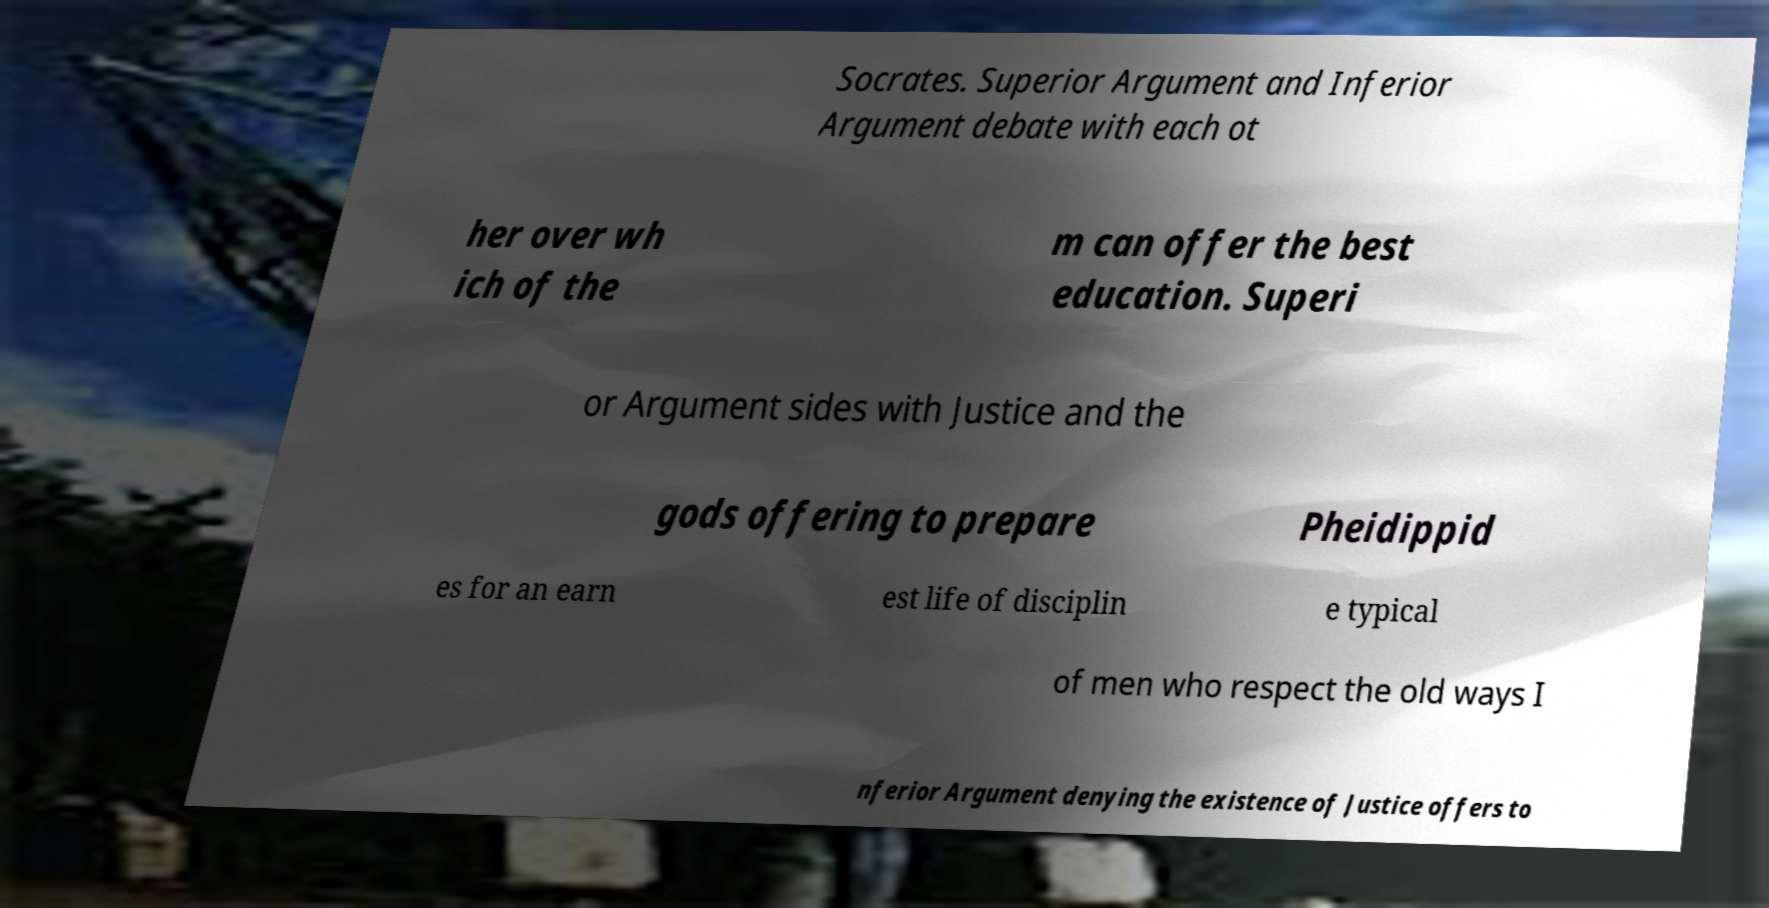Can you accurately transcribe the text from the provided image for me? Socrates. Superior Argument and Inferior Argument debate with each ot her over wh ich of the m can offer the best education. Superi or Argument sides with Justice and the gods offering to prepare Pheidippid es for an earn est life of disciplin e typical of men who respect the old ways I nferior Argument denying the existence of Justice offers to 